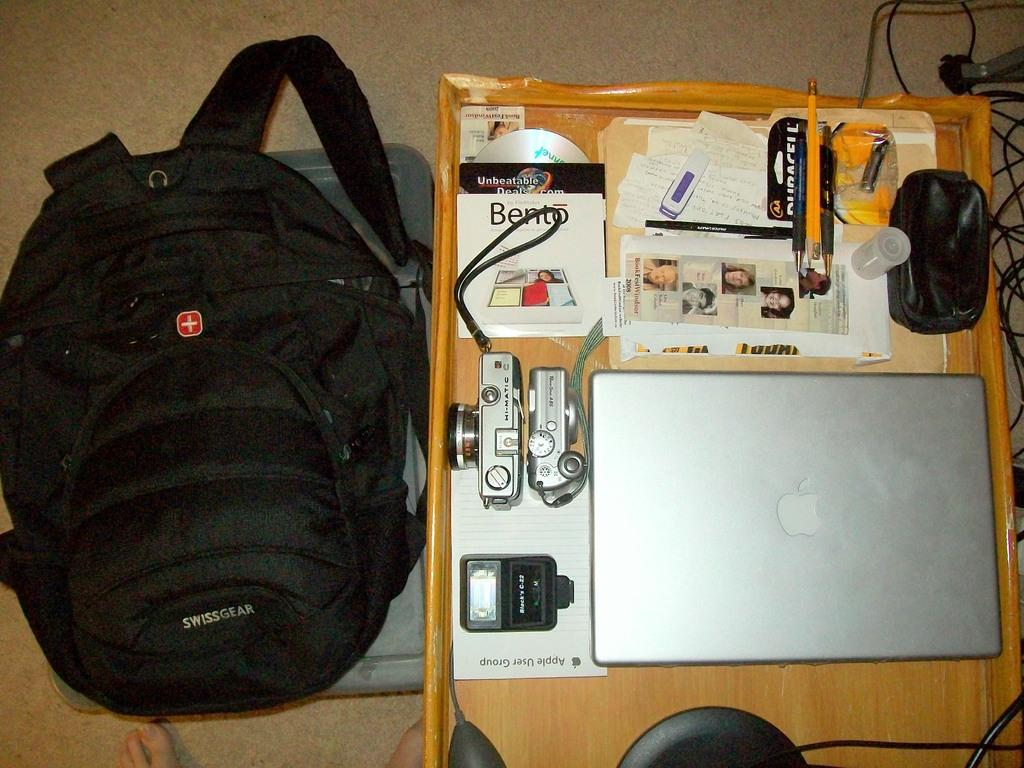<image>
Offer a succinct explanation of the picture presented. A black Swiss Gear backpack sits next to some electronics gear. 